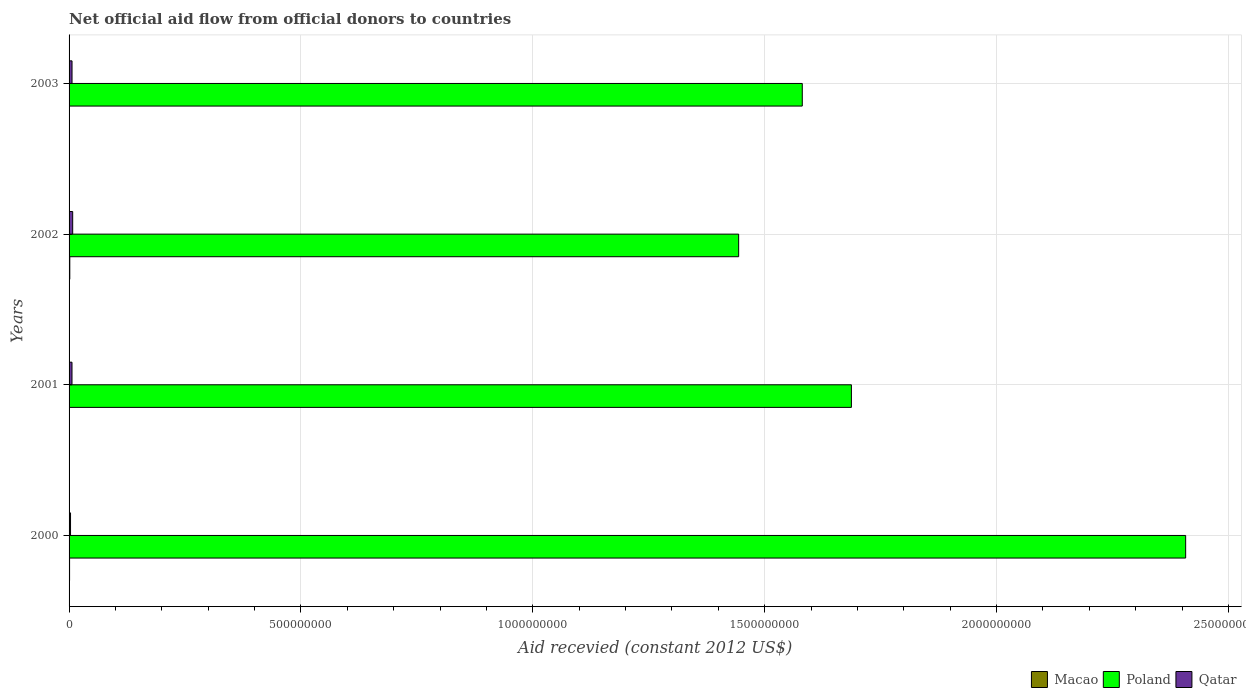How many different coloured bars are there?
Your answer should be very brief. 3. How many groups of bars are there?
Provide a short and direct response. 4. Are the number of bars per tick equal to the number of legend labels?
Offer a very short reply. Yes. How many bars are there on the 3rd tick from the top?
Your answer should be very brief. 3. How many bars are there on the 1st tick from the bottom?
Ensure brevity in your answer.  3. In how many cases, is the number of bars for a given year not equal to the number of legend labels?
Your answer should be compact. 0. What is the total aid received in Qatar in 2002?
Your response must be concise. 7.79e+06. Across all years, what is the maximum total aid received in Qatar?
Provide a succinct answer. 7.79e+06. Across all years, what is the minimum total aid received in Qatar?
Provide a succinct answer. 3.14e+06. In which year was the total aid received in Macao maximum?
Give a very brief answer. 2002. In which year was the total aid received in Poland minimum?
Offer a terse response. 2002. What is the total total aid received in Qatar in the graph?
Your response must be concise. 2.36e+07. What is the difference between the total aid received in Qatar in 2000 and that in 2001?
Provide a short and direct response. -3.16e+06. What is the difference between the total aid received in Poland in 2001 and the total aid received in Macao in 2002?
Provide a short and direct response. 1.69e+09. What is the average total aid received in Poland per year?
Keep it short and to the point. 1.78e+09. In the year 2001, what is the difference between the total aid received in Macao and total aid received in Poland?
Give a very brief answer. -1.69e+09. What is the ratio of the total aid received in Qatar in 2000 to that in 2002?
Offer a very short reply. 0.4. Is the difference between the total aid received in Macao in 2001 and 2003 greater than the difference between the total aid received in Poland in 2001 and 2003?
Your answer should be compact. No. What is the difference between the highest and the second highest total aid received in Qatar?
Offer a terse response. 1.41e+06. What is the difference between the highest and the lowest total aid received in Macao?
Keep it short and to the point. 1.40e+06. Is the sum of the total aid received in Poland in 2001 and 2002 greater than the maximum total aid received in Macao across all years?
Offer a very short reply. Yes. What does the 1st bar from the top in 2001 represents?
Your answer should be compact. Qatar. What does the 1st bar from the bottom in 2002 represents?
Your answer should be very brief. Macao. How many bars are there?
Offer a very short reply. 12. Are all the bars in the graph horizontal?
Make the answer very short. Yes. What is the difference between two consecutive major ticks on the X-axis?
Your answer should be compact. 5.00e+08. Are the values on the major ticks of X-axis written in scientific E-notation?
Your answer should be very brief. No. Does the graph contain any zero values?
Offer a very short reply. No. What is the title of the graph?
Keep it short and to the point. Net official aid flow from official donors to countries. What is the label or title of the X-axis?
Give a very brief answer. Aid recevied (constant 2012 US$). What is the Aid recevied (constant 2012 US$) of Macao in 2000?
Provide a short and direct response. 1.08e+06. What is the Aid recevied (constant 2012 US$) of Poland in 2000?
Offer a terse response. 2.41e+09. What is the Aid recevied (constant 2012 US$) in Qatar in 2000?
Your response must be concise. 3.14e+06. What is the Aid recevied (constant 2012 US$) in Macao in 2001?
Offer a very short reply. 8.60e+05. What is the Aid recevied (constant 2012 US$) in Poland in 2001?
Your answer should be compact. 1.69e+09. What is the Aid recevied (constant 2012 US$) of Qatar in 2001?
Offer a terse response. 6.30e+06. What is the Aid recevied (constant 2012 US$) in Macao in 2002?
Your answer should be compact. 1.58e+06. What is the Aid recevied (constant 2012 US$) in Poland in 2002?
Offer a terse response. 1.44e+09. What is the Aid recevied (constant 2012 US$) in Qatar in 2002?
Provide a succinct answer. 7.79e+06. What is the Aid recevied (constant 2012 US$) in Poland in 2003?
Your answer should be compact. 1.58e+09. What is the Aid recevied (constant 2012 US$) of Qatar in 2003?
Your answer should be compact. 6.38e+06. Across all years, what is the maximum Aid recevied (constant 2012 US$) of Macao?
Provide a succinct answer. 1.58e+06. Across all years, what is the maximum Aid recevied (constant 2012 US$) in Poland?
Provide a succinct answer. 2.41e+09. Across all years, what is the maximum Aid recevied (constant 2012 US$) in Qatar?
Provide a succinct answer. 7.79e+06. Across all years, what is the minimum Aid recevied (constant 2012 US$) of Poland?
Give a very brief answer. 1.44e+09. Across all years, what is the minimum Aid recevied (constant 2012 US$) in Qatar?
Give a very brief answer. 3.14e+06. What is the total Aid recevied (constant 2012 US$) of Macao in the graph?
Your response must be concise. 3.70e+06. What is the total Aid recevied (constant 2012 US$) of Poland in the graph?
Provide a succinct answer. 7.12e+09. What is the total Aid recevied (constant 2012 US$) of Qatar in the graph?
Provide a short and direct response. 2.36e+07. What is the difference between the Aid recevied (constant 2012 US$) in Poland in 2000 and that in 2001?
Offer a terse response. 7.21e+08. What is the difference between the Aid recevied (constant 2012 US$) in Qatar in 2000 and that in 2001?
Your response must be concise. -3.16e+06. What is the difference between the Aid recevied (constant 2012 US$) of Macao in 2000 and that in 2002?
Provide a succinct answer. -5.00e+05. What is the difference between the Aid recevied (constant 2012 US$) in Poland in 2000 and that in 2002?
Your response must be concise. 9.64e+08. What is the difference between the Aid recevied (constant 2012 US$) in Qatar in 2000 and that in 2002?
Your answer should be very brief. -4.65e+06. What is the difference between the Aid recevied (constant 2012 US$) of Poland in 2000 and that in 2003?
Your response must be concise. 8.27e+08. What is the difference between the Aid recevied (constant 2012 US$) of Qatar in 2000 and that in 2003?
Give a very brief answer. -3.24e+06. What is the difference between the Aid recevied (constant 2012 US$) in Macao in 2001 and that in 2002?
Your answer should be compact. -7.20e+05. What is the difference between the Aid recevied (constant 2012 US$) in Poland in 2001 and that in 2002?
Ensure brevity in your answer.  2.43e+08. What is the difference between the Aid recevied (constant 2012 US$) of Qatar in 2001 and that in 2002?
Offer a terse response. -1.49e+06. What is the difference between the Aid recevied (constant 2012 US$) of Macao in 2001 and that in 2003?
Offer a very short reply. 6.80e+05. What is the difference between the Aid recevied (constant 2012 US$) of Poland in 2001 and that in 2003?
Provide a succinct answer. 1.06e+08. What is the difference between the Aid recevied (constant 2012 US$) of Macao in 2002 and that in 2003?
Your answer should be compact. 1.40e+06. What is the difference between the Aid recevied (constant 2012 US$) in Poland in 2002 and that in 2003?
Your answer should be very brief. -1.37e+08. What is the difference between the Aid recevied (constant 2012 US$) of Qatar in 2002 and that in 2003?
Your answer should be very brief. 1.41e+06. What is the difference between the Aid recevied (constant 2012 US$) in Macao in 2000 and the Aid recevied (constant 2012 US$) in Poland in 2001?
Your answer should be compact. -1.69e+09. What is the difference between the Aid recevied (constant 2012 US$) in Macao in 2000 and the Aid recevied (constant 2012 US$) in Qatar in 2001?
Keep it short and to the point. -5.22e+06. What is the difference between the Aid recevied (constant 2012 US$) in Poland in 2000 and the Aid recevied (constant 2012 US$) in Qatar in 2001?
Offer a terse response. 2.40e+09. What is the difference between the Aid recevied (constant 2012 US$) of Macao in 2000 and the Aid recevied (constant 2012 US$) of Poland in 2002?
Keep it short and to the point. -1.44e+09. What is the difference between the Aid recevied (constant 2012 US$) in Macao in 2000 and the Aid recevied (constant 2012 US$) in Qatar in 2002?
Offer a terse response. -6.71e+06. What is the difference between the Aid recevied (constant 2012 US$) in Poland in 2000 and the Aid recevied (constant 2012 US$) in Qatar in 2002?
Provide a short and direct response. 2.40e+09. What is the difference between the Aid recevied (constant 2012 US$) of Macao in 2000 and the Aid recevied (constant 2012 US$) of Poland in 2003?
Your answer should be compact. -1.58e+09. What is the difference between the Aid recevied (constant 2012 US$) in Macao in 2000 and the Aid recevied (constant 2012 US$) in Qatar in 2003?
Make the answer very short. -5.30e+06. What is the difference between the Aid recevied (constant 2012 US$) in Poland in 2000 and the Aid recevied (constant 2012 US$) in Qatar in 2003?
Offer a very short reply. 2.40e+09. What is the difference between the Aid recevied (constant 2012 US$) in Macao in 2001 and the Aid recevied (constant 2012 US$) in Poland in 2002?
Ensure brevity in your answer.  -1.44e+09. What is the difference between the Aid recevied (constant 2012 US$) in Macao in 2001 and the Aid recevied (constant 2012 US$) in Qatar in 2002?
Your answer should be compact. -6.93e+06. What is the difference between the Aid recevied (constant 2012 US$) of Poland in 2001 and the Aid recevied (constant 2012 US$) of Qatar in 2002?
Provide a short and direct response. 1.68e+09. What is the difference between the Aid recevied (constant 2012 US$) in Macao in 2001 and the Aid recevied (constant 2012 US$) in Poland in 2003?
Provide a succinct answer. -1.58e+09. What is the difference between the Aid recevied (constant 2012 US$) in Macao in 2001 and the Aid recevied (constant 2012 US$) in Qatar in 2003?
Your answer should be compact. -5.52e+06. What is the difference between the Aid recevied (constant 2012 US$) in Poland in 2001 and the Aid recevied (constant 2012 US$) in Qatar in 2003?
Make the answer very short. 1.68e+09. What is the difference between the Aid recevied (constant 2012 US$) in Macao in 2002 and the Aid recevied (constant 2012 US$) in Poland in 2003?
Your answer should be compact. -1.58e+09. What is the difference between the Aid recevied (constant 2012 US$) in Macao in 2002 and the Aid recevied (constant 2012 US$) in Qatar in 2003?
Offer a very short reply. -4.80e+06. What is the difference between the Aid recevied (constant 2012 US$) of Poland in 2002 and the Aid recevied (constant 2012 US$) of Qatar in 2003?
Ensure brevity in your answer.  1.44e+09. What is the average Aid recevied (constant 2012 US$) in Macao per year?
Ensure brevity in your answer.  9.25e+05. What is the average Aid recevied (constant 2012 US$) in Poland per year?
Make the answer very short. 1.78e+09. What is the average Aid recevied (constant 2012 US$) of Qatar per year?
Your answer should be compact. 5.90e+06. In the year 2000, what is the difference between the Aid recevied (constant 2012 US$) of Macao and Aid recevied (constant 2012 US$) of Poland?
Offer a very short reply. -2.41e+09. In the year 2000, what is the difference between the Aid recevied (constant 2012 US$) in Macao and Aid recevied (constant 2012 US$) in Qatar?
Provide a succinct answer. -2.06e+06. In the year 2000, what is the difference between the Aid recevied (constant 2012 US$) in Poland and Aid recevied (constant 2012 US$) in Qatar?
Provide a succinct answer. 2.40e+09. In the year 2001, what is the difference between the Aid recevied (constant 2012 US$) of Macao and Aid recevied (constant 2012 US$) of Poland?
Offer a very short reply. -1.69e+09. In the year 2001, what is the difference between the Aid recevied (constant 2012 US$) of Macao and Aid recevied (constant 2012 US$) of Qatar?
Make the answer very short. -5.44e+06. In the year 2001, what is the difference between the Aid recevied (constant 2012 US$) in Poland and Aid recevied (constant 2012 US$) in Qatar?
Your response must be concise. 1.68e+09. In the year 2002, what is the difference between the Aid recevied (constant 2012 US$) in Macao and Aid recevied (constant 2012 US$) in Poland?
Ensure brevity in your answer.  -1.44e+09. In the year 2002, what is the difference between the Aid recevied (constant 2012 US$) of Macao and Aid recevied (constant 2012 US$) of Qatar?
Give a very brief answer. -6.21e+06. In the year 2002, what is the difference between the Aid recevied (constant 2012 US$) of Poland and Aid recevied (constant 2012 US$) of Qatar?
Your response must be concise. 1.44e+09. In the year 2003, what is the difference between the Aid recevied (constant 2012 US$) in Macao and Aid recevied (constant 2012 US$) in Poland?
Keep it short and to the point. -1.58e+09. In the year 2003, what is the difference between the Aid recevied (constant 2012 US$) of Macao and Aid recevied (constant 2012 US$) of Qatar?
Your answer should be compact. -6.20e+06. In the year 2003, what is the difference between the Aid recevied (constant 2012 US$) in Poland and Aid recevied (constant 2012 US$) in Qatar?
Keep it short and to the point. 1.57e+09. What is the ratio of the Aid recevied (constant 2012 US$) in Macao in 2000 to that in 2001?
Your answer should be compact. 1.26. What is the ratio of the Aid recevied (constant 2012 US$) in Poland in 2000 to that in 2001?
Offer a very short reply. 1.43. What is the ratio of the Aid recevied (constant 2012 US$) of Qatar in 2000 to that in 2001?
Provide a succinct answer. 0.5. What is the ratio of the Aid recevied (constant 2012 US$) of Macao in 2000 to that in 2002?
Keep it short and to the point. 0.68. What is the ratio of the Aid recevied (constant 2012 US$) of Poland in 2000 to that in 2002?
Ensure brevity in your answer.  1.67. What is the ratio of the Aid recevied (constant 2012 US$) in Qatar in 2000 to that in 2002?
Your answer should be very brief. 0.4. What is the ratio of the Aid recevied (constant 2012 US$) in Poland in 2000 to that in 2003?
Make the answer very short. 1.52. What is the ratio of the Aid recevied (constant 2012 US$) of Qatar in 2000 to that in 2003?
Make the answer very short. 0.49. What is the ratio of the Aid recevied (constant 2012 US$) in Macao in 2001 to that in 2002?
Keep it short and to the point. 0.54. What is the ratio of the Aid recevied (constant 2012 US$) of Poland in 2001 to that in 2002?
Make the answer very short. 1.17. What is the ratio of the Aid recevied (constant 2012 US$) in Qatar in 2001 to that in 2002?
Your answer should be very brief. 0.81. What is the ratio of the Aid recevied (constant 2012 US$) in Macao in 2001 to that in 2003?
Your answer should be compact. 4.78. What is the ratio of the Aid recevied (constant 2012 US$) in Poland in 2001 to that in 2003?
Your response must be concise. 1.07. What is the ratio of the Aid recevied (constant 2012 US$) in Qatar in 2001 to that in 2003?
Offer a very short reply. 0.99. What is the ratio of the Aid recevied (constant 2012 US$) in Macao in 2002 to that in 2003?
Provide a short and direct response. 8.78. What is the ratio of the Aid recevied (constant 2012 US$) of Poland in 2002 to that in 2003?
Provide a short and direct response. 0.91. What is the ratio of the Aid recevied (constant 2012 US$) of Qatar in 2002 to that in 2003?
Offer a very short reply. 1.22. What is the difference between the highest and the second highest Aid recevied (constant 2012 US$) of Macao?
Keep it short and to the point. 5.00e+05. What is the difference between the highest and the second highest Aid recevied (constant 2012 US$) of Poland?
Give a very brief answer. 7.21e+08. What is the difference between the highest and the second highest Aid recevied (constant 2012 US$) of Qatar?
Ensure brevity in your answer.  1.41e+06. What is the difference between the highest and the lowest Aid recevied (constant 2012 US$) in Macao?
Your answer should be very brief. 1.40e+06. What is the difference between the highest and the lowest Aid recevied (constant 2012 US$) of Poland?
Keep it short and to the point. 9.64e+08. What is the difference between the highest and the lowest Aid recevied (constant 2012 US$) of Qatar?
Make the answer very short. 4.65e+06. 